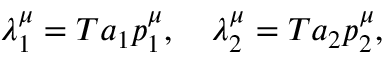<formula> <loc_0><loc_0><loc_500><loc_500>\lambda _ { 1 } ^ { \mu } = T a _ { 1 } p _ { 1 } ^ { \mu } , \quad \lambda _ { 2 } ^ { \mu } = T a _ { 2 } p _ { 2 } ^ { \mu } ,</formula> 